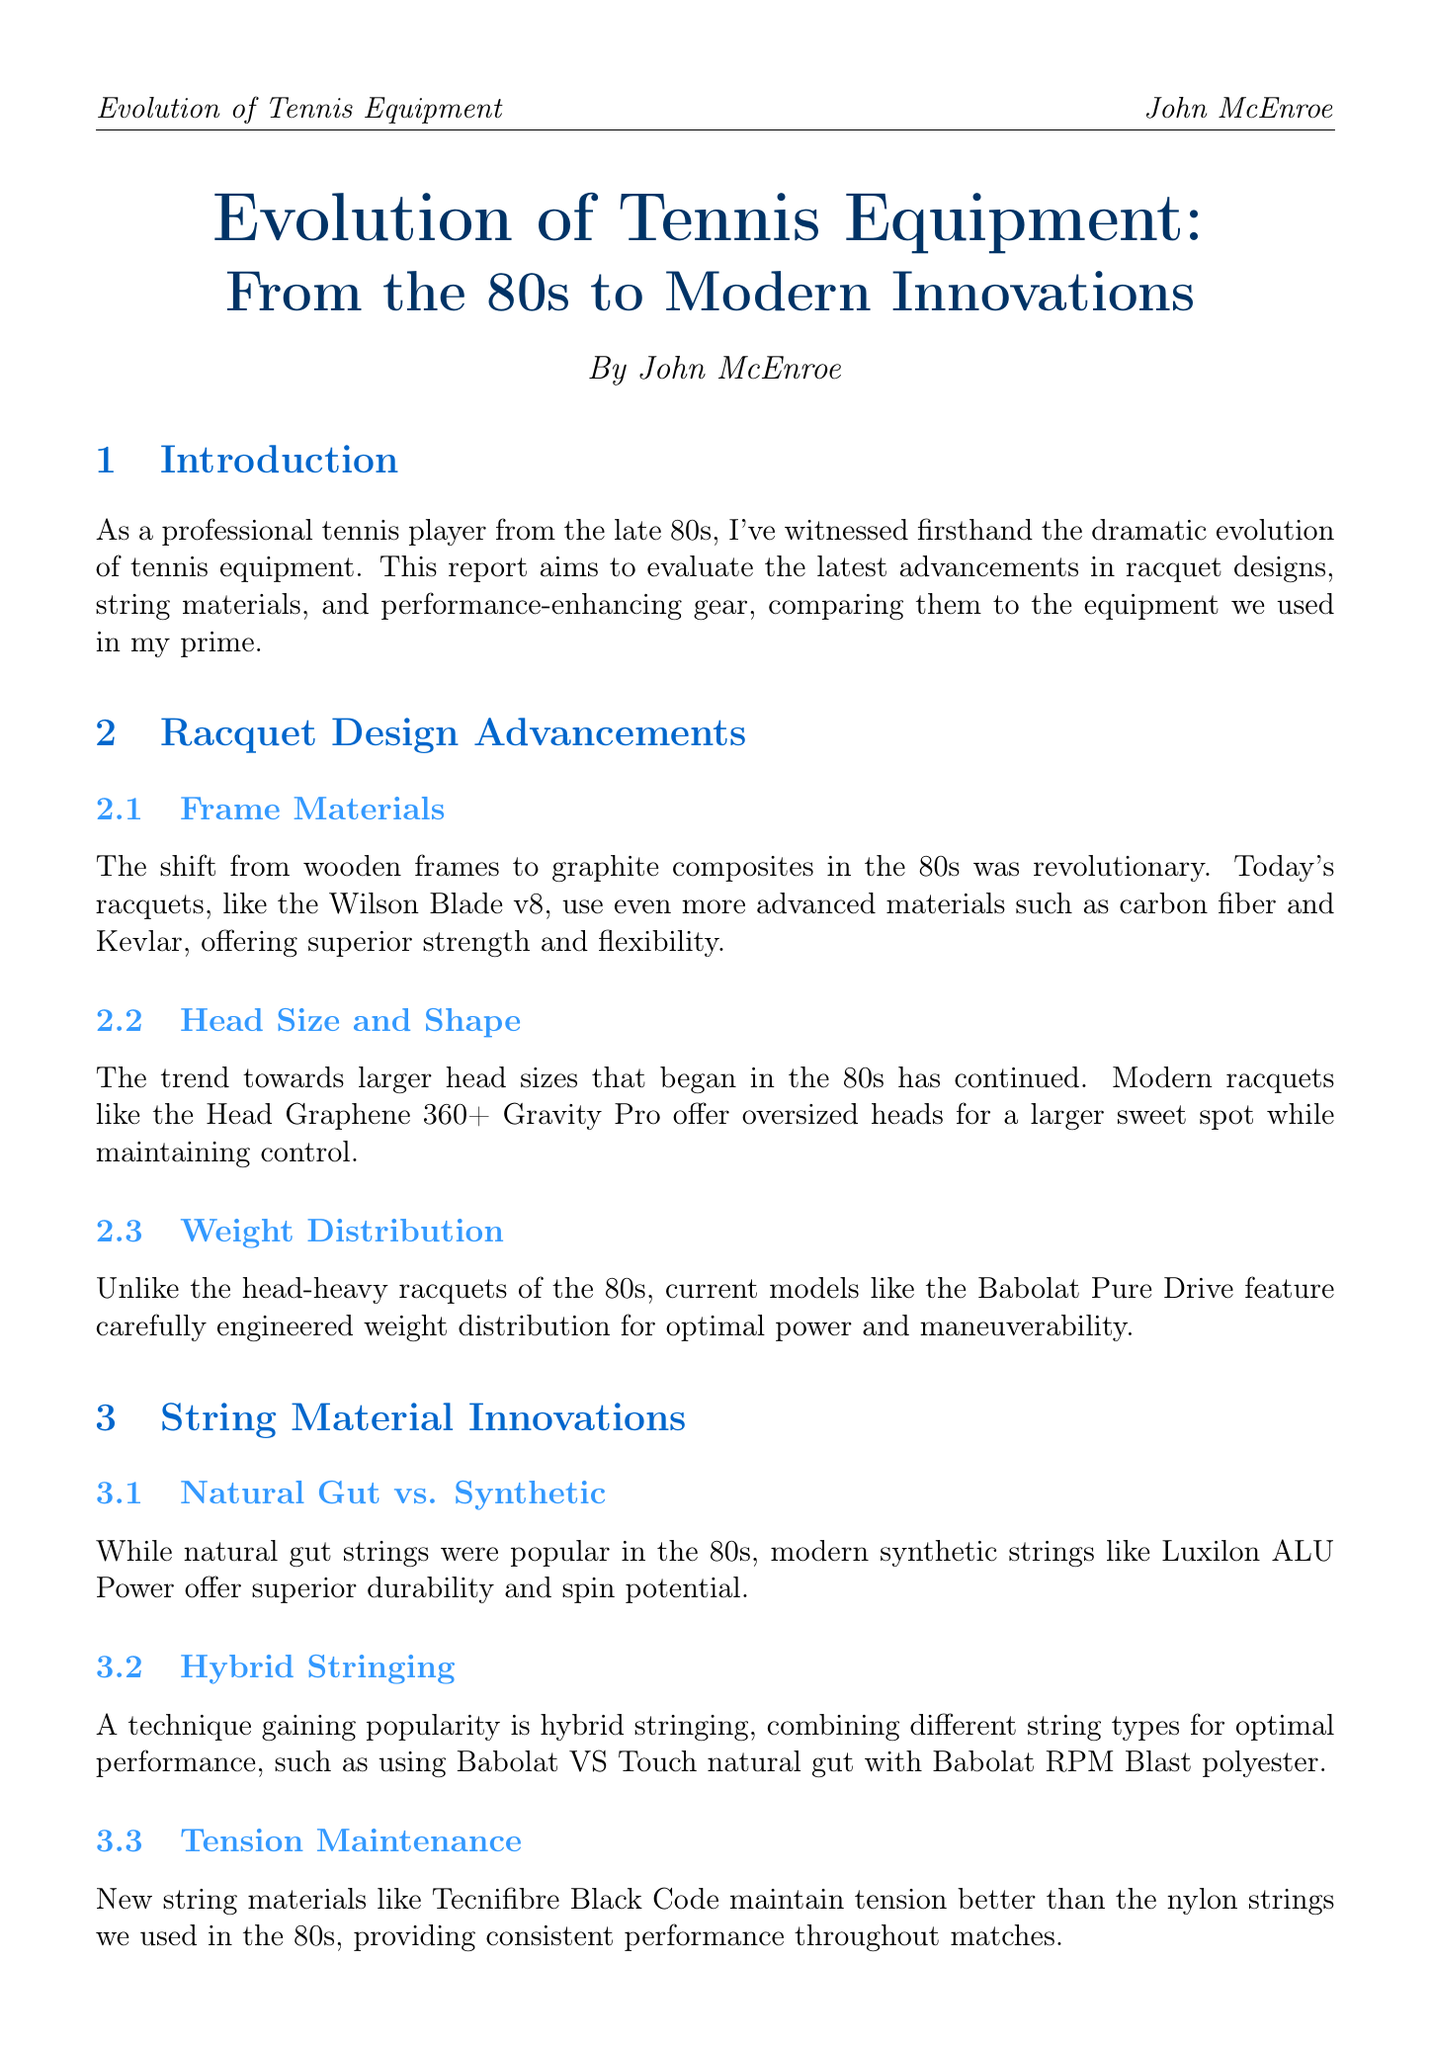what is the title of the report? The title of the report is provided in the document's introduction section.
Answer: Evolution of Tennis Equipment: From the 80s to Modern Innovations who is the author of the report? The author's name is mentioned at the beginning of the document.
Answer: John McEnroe what technology is used in modern racquets for strength and flexibility? The document discusses advanced materials in the racquet section, particularly related to frame materials.
Answer: carbon fiber and Kevlar what is a notable string material innovation mentioned? The document highlights specific innovations in string materials, particularly a comparison of types.
Answer: Luxilon ALU Power what footwear brand is mentioned for its modern features? The performance-enhancing gear section lists a brand that's known for its advanced shoes.
Answer: Nike how did modern racquet designs influence playing style? The impact of equipment on playing style is discussed in the document's last section.
Answer: more aggressive baseline game how many notable equipment manufacturers are listed in the appendix? The document contains an appendix that enumerates various equipment manufacturers.
Answer: seven what is an example of hybrid stringing? The string material innovations section provides a specific example of hybrid stringing techniques.
Answer: Babolat VS Touch with Babolat RPM Blast what has improved in modern clothing compared to the past? The clothing section describes advancements in fabric technology over time.
Answer: moisture management and temperature regulation 